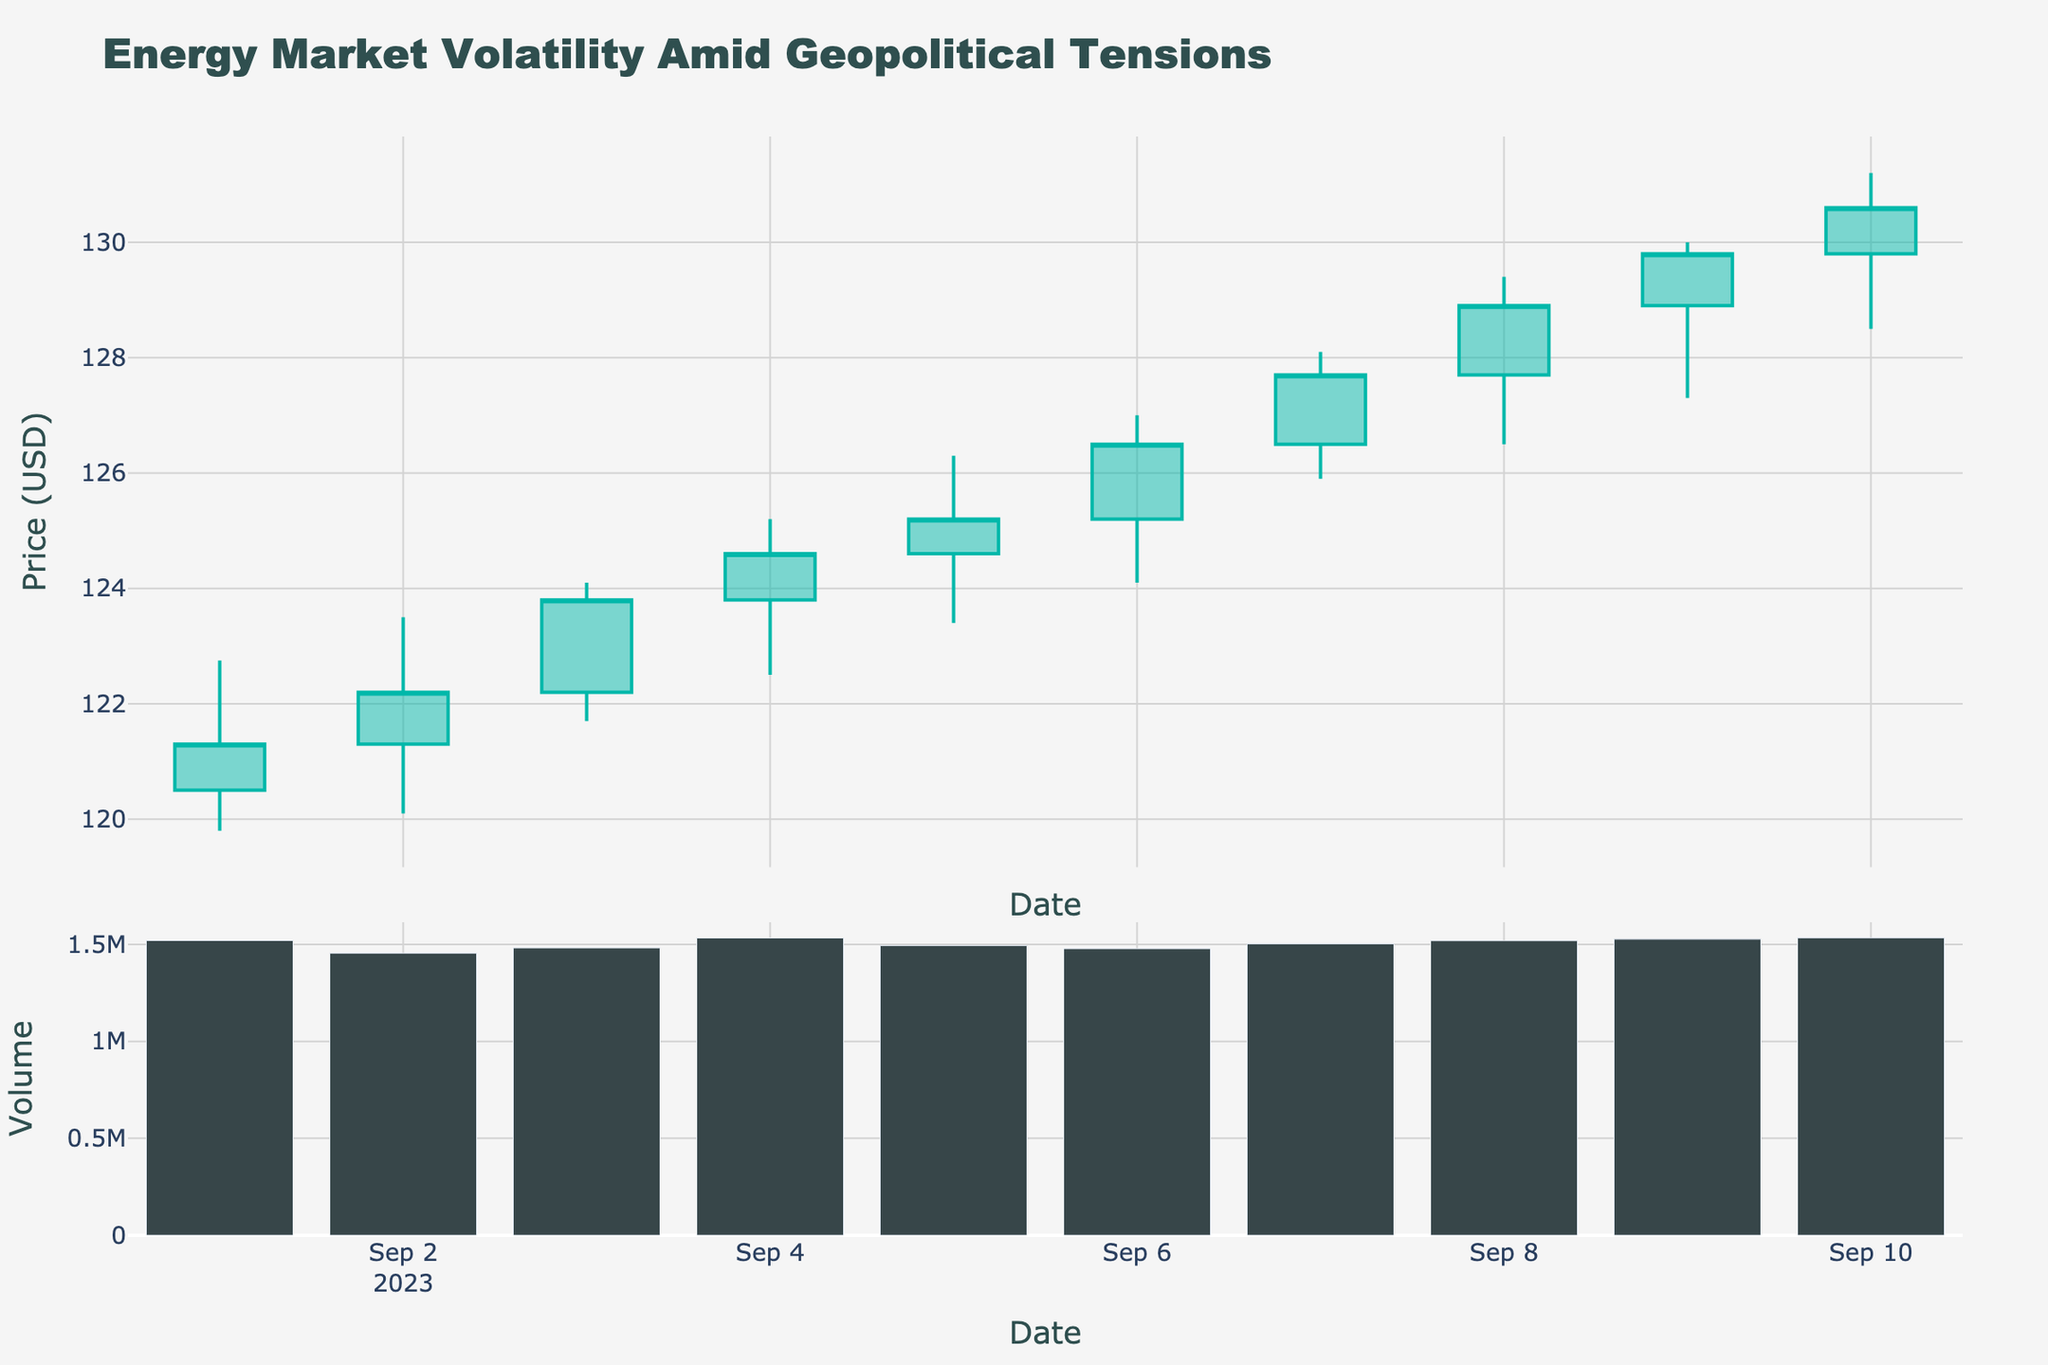What is the title of the plot? The title is usually located at the top of the plot and provides a brief description of what the plot represents. Here, it states "Energy Market Volatility Amid Geopolitical Tensions."
Answer: Energy Market Volatility Amid Geopolitical Tensions How many data points are displayed on the plot? Counting the number of dates on the x-axis tells us how many candlesticks (data points) are shown. There are 10 dates, from 2023-09-01 to 2023-09-10.
Answer: 10 What are the colors used to indicate increasing and decreasing prices in the candlestick plot? Candlestick charts use different colors to distinguish between increasing and decreasing prices. The increasing prices are shown in a color closer to teal, while the decreasing prices are shown in a color closer to red.
Answer: Teal and Red Which date had the highest trading volume, and what was it? The bar chart below the candlestick plot shows the trading volume for each date. By finding the tallest bar, we see that September 10 had the highest volume. The exact volume is 1,534,000.
Answer: 2023-09-10, 1,534,000 What is the closing price on the first day and the last day shown in the plot? Look at the closing price on September 1 and September 10 in the candlestick plot. The closing price is indicated by the top of the candlestick for days when prices increased and the bottom when prices decreased. On September 1, the closing price was 121.30, and on September 10, it was 130.60.
Answer: 121.30 and 130.60 Did the energy market experience more increasing or decreasing days within the given dates? Count the number of increasing candlesticks (teal) and compare them to the number of decreasing candlesticks (red). There are more increasing candlesticks, indicating more days when the closing price was higher than the opening price.
Answer: More increasing days What was the highest price reached during the period and on which date? The top of the highest candlestick indicates the highest price reached. The highest price is 131.20 on September 10.
Answer: 131.20 on 2023-09-10 On which date did the energy market have the smallest price range, and what was that range? Calculate the daily price range (High - Low) for each date. The smallest range is on September 1, with a range of 122.75 - 119.80 = 2.95.
Answer: 2023-09-01, 2.95 What was the average trading volume over the given dates? Sum all the trading volumes for each date and divide by the number of dates. The total volume is 1,520,000 + 1,455,000 + 1,482,000 + 1,533,000 + 1,494,000 + 1,478,000 + 1,503,000 + 1,519,000 + 1,527,000 + 1,534,000 = 14,045,000. Divide by 10 dates to get the average volume, 14,045,000 / 10 = 1,404,500.
Answer: 1,404,500 